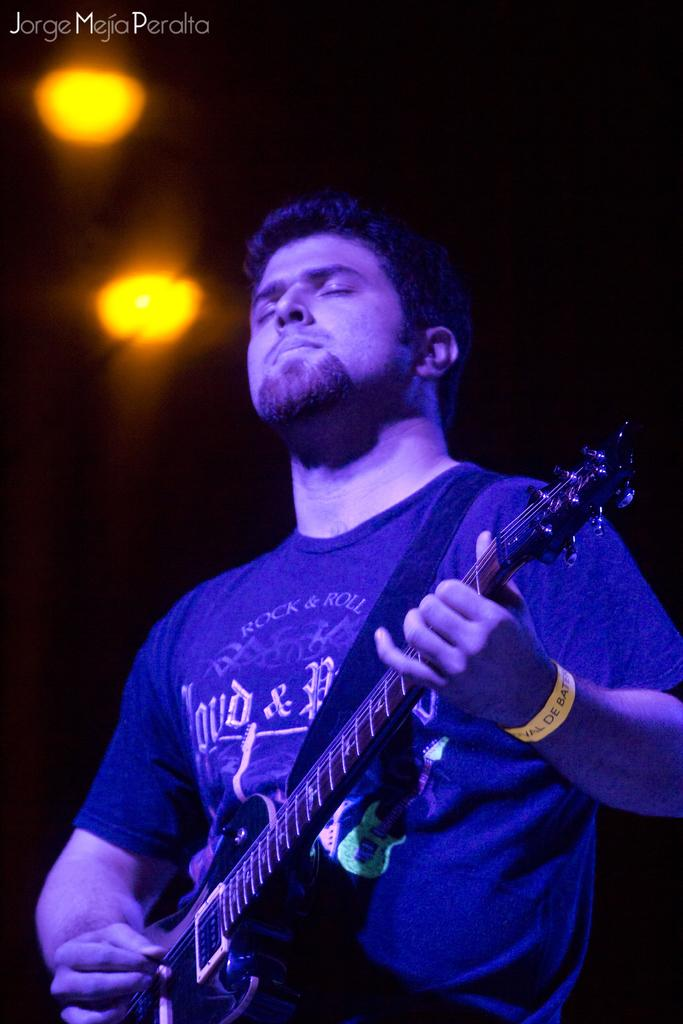What type of event is depicted in the image? The image is from a musical concert. Can you describe the person in the image? There is a man in the image wearing a blue t-shirt. What is the man holding in the image? The man is holding a guitar. What is the man doing with the guitar? The man is playing the guitar. What lighting can be seen in the image? There are two yellow lights visible in the image. How many cracks can be seen on the guitar in the image? There are no cracks visible on the guitar in the image. 